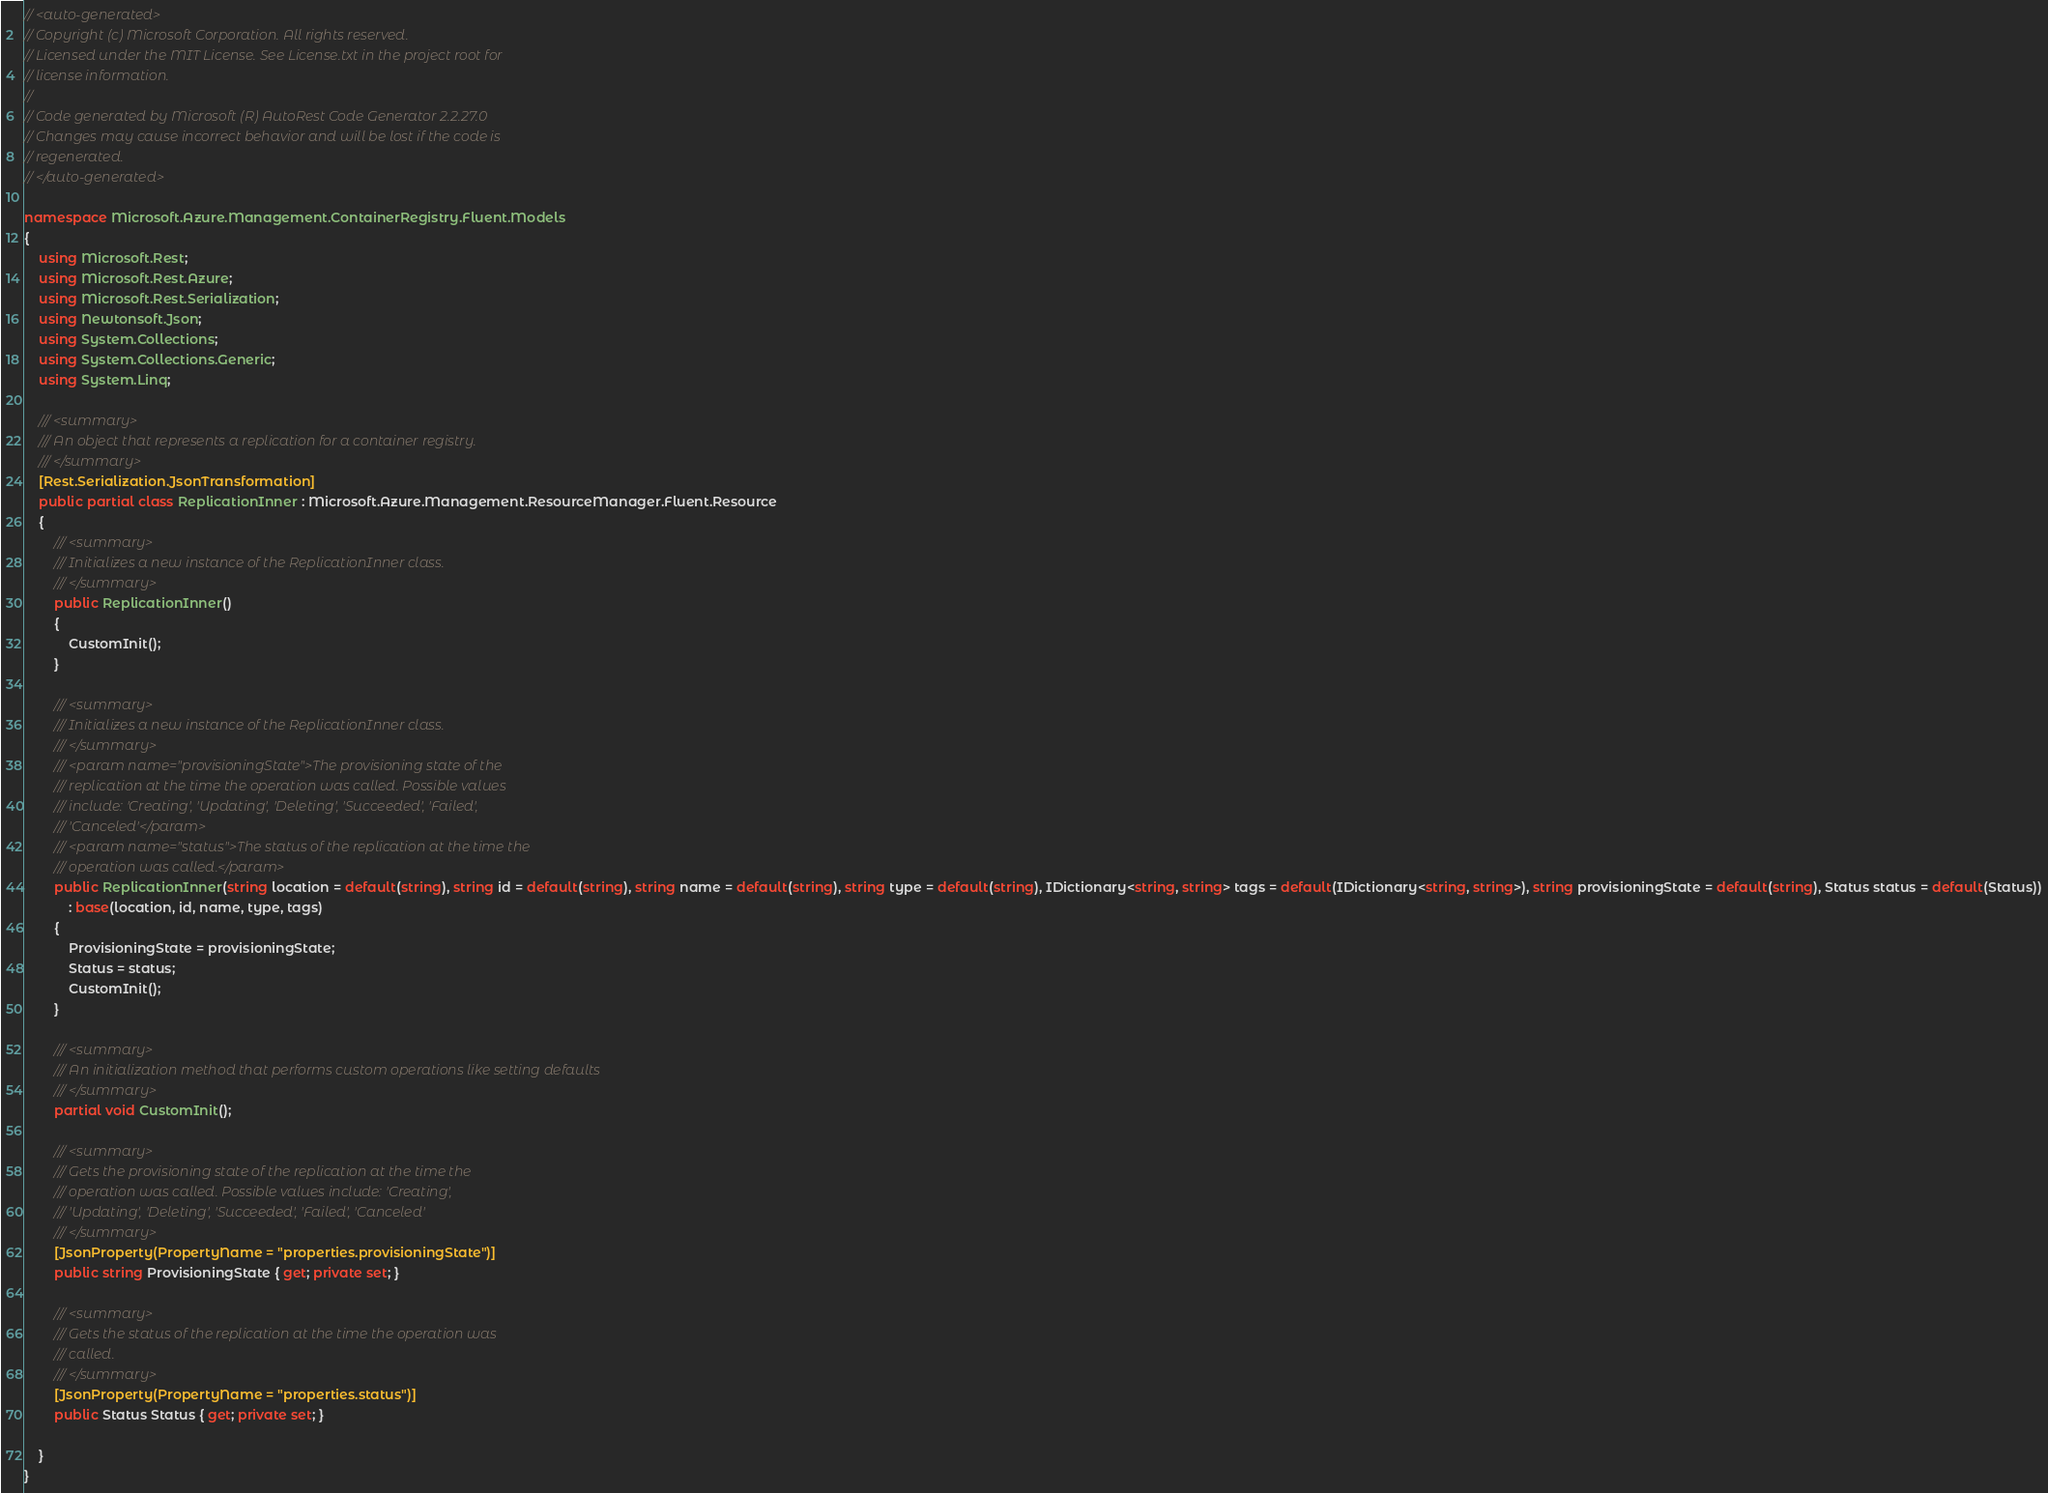<code> <loc_0><loc_0><loc_500><loc_500><_C#_>// <auto-generated>
// Copyright (c) Microsoft Corporation. All rights reserved.
// Licensed under the MIT License. See License.txt in the project root for
// license information.
//
// Code generated by Microsoft (R) AutoRest Code Generator 2.2.27.0
// Changes may cause incorrect behavior and will be lost if the code is
// regenerated.
// </auto-generated>

namespace Microsoft.Azure.Management.ContainerRegistry.Fluent.Models
{
    using Microsoft.Rest;
    using Microsoft.Rest.Azure;
    using Microsoft.Rest.Serialization;
    using Newtonsoft.Json;
    using System.Collections;
    using System.Collections.Generic;
    using System.Linq;

    /// <summary>
    /// An object that represents a replication for a container registry.
    /// </summary>
    [Rest.Serialization.JsonTransformation]
    public partial class ReplicationInner : Microsoft.Azure.Management.ResourceManager.Fluent.Resource
    {
        /// <summary>
        /// Initializes a new instance of the ReplicationInner class.
        /// </summary>
        public ReplicationInner()
        {
            CustomInit();
        }

        /// <summary>
        /// Initializes a new instance of the ReplicationInner class.
        /// </summary>
        /// <param name="provisioningState">The provisioning state of the
        /// replication at the time the operation was called. Possible values
        /// include: 'Creating', 'Updating', 'Deleting', 'Succeeded', 'Failed',
        /// 'Canceled'</param>
        /// <param name="status">The status of the replication at the time the
        /// operation was called.</param>
        public ReplicationInner(string location = default(string), string id = default(string), string name = default(string), string type = default(string), IDictionary<string, string> tags = default(IDictionary<string, string>), string provisioningState = default(string), Status status = default(Status))
            : base(location, id, name, type, tags)
        {
            ProvisioningState = provisioningState;
            Status = status;
            CustomInit();
        }

        /// <summary>
        /// An initialization method that performs custom operations like setting defaults
        /// </summary>
        partial void CustomInit();

        /// <summary>
        /// Gets the provisioning state of the replication at the time the
        /// operation was called. Possible values include: 'Creating',
        /// 'Updating', 'Deleting', 'Succeeded', 'Failed', 'Canceled'
        /// </summary>
        [JsonProperty(PropertyName = "properties.provisioningState")]
        public string ProvisioningState { get; private set; }

        /// <summary>
        /// Gets the status of the replication at the time the operation was
        /// called.
        /// </summary>
        [JsonProperty(PropertyName = "properties.status")]
        public Status Status { get; private set; }

    }
}
</code> 